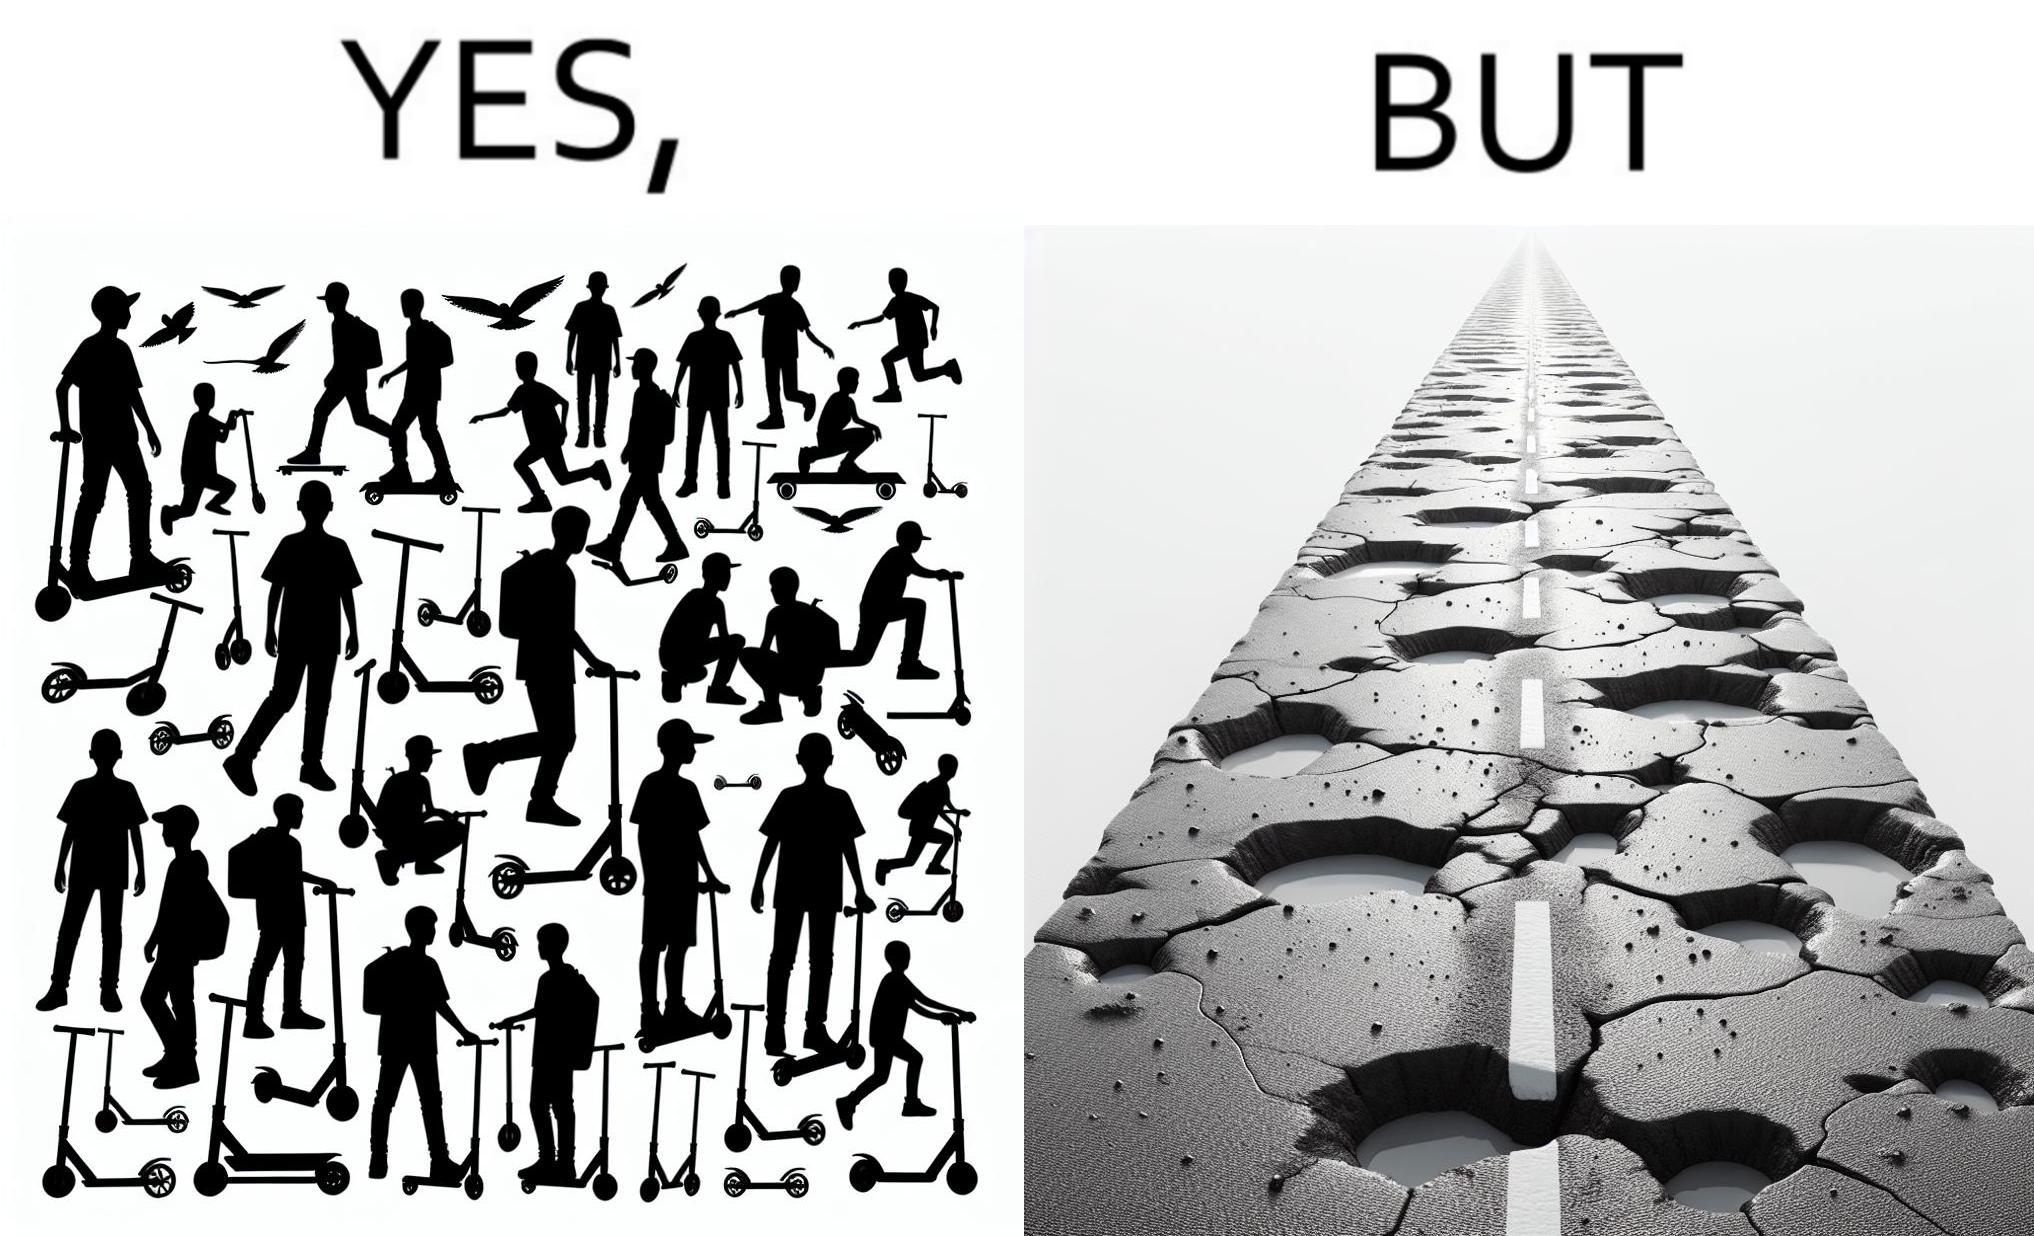What does this image depict? The image is ironic, because even after when the skateboard scooters are available for someone to ride but the road has many potholes that it is not suitable to ride the scooters on such roads 